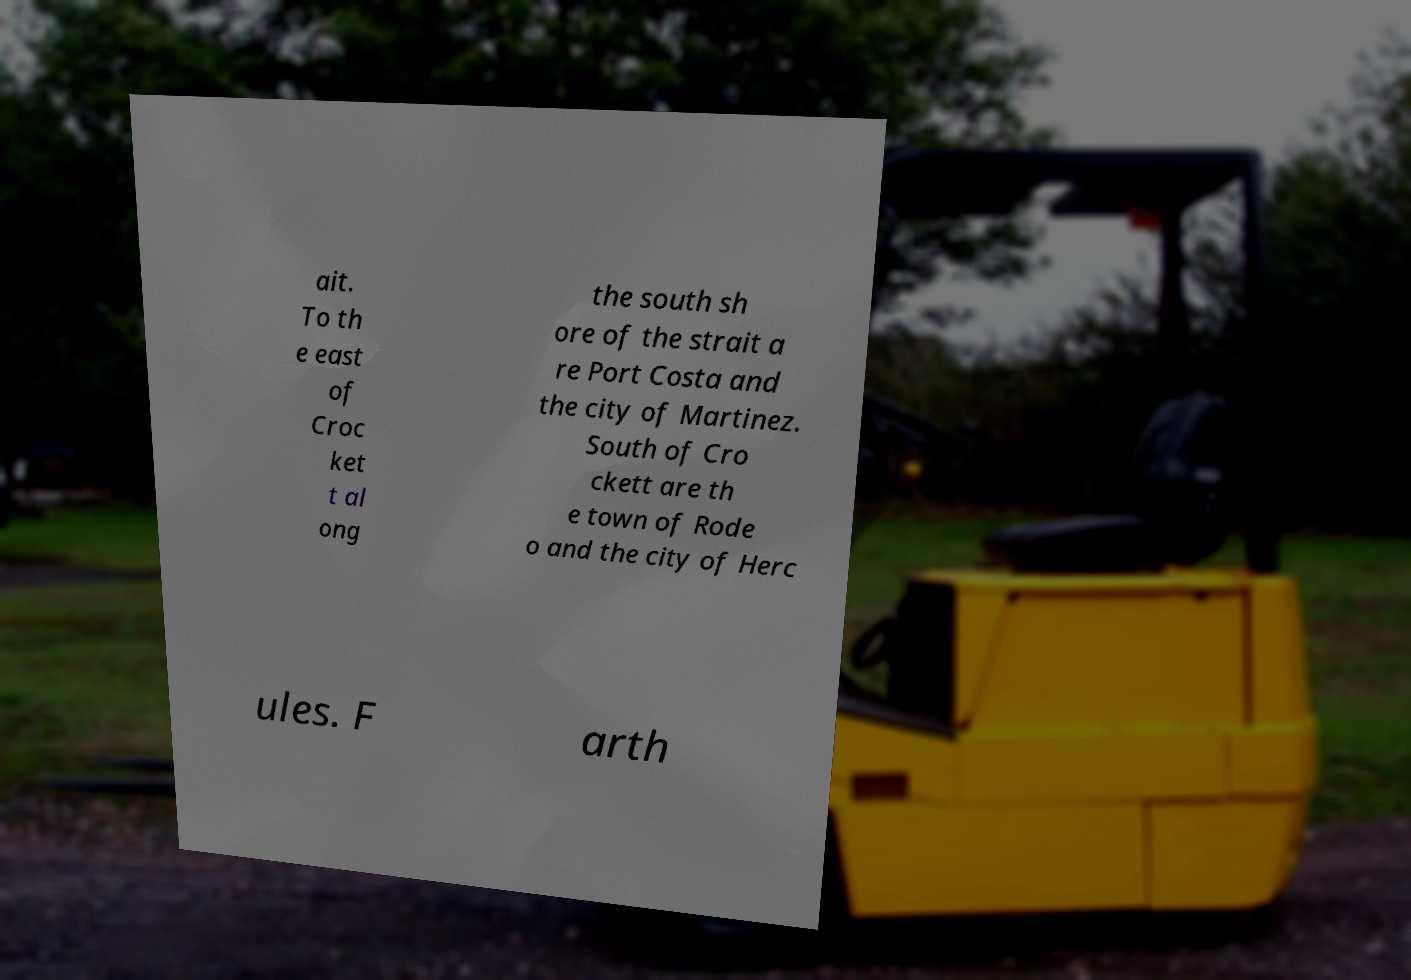Can you read and provide the text displayed in the image?This photo seems to have some interesting text. Can you extract and type it out for me? ait. To th e east of Croc ket t al ong the south sh ore of the strait a re Port Costa and the city of Martinez. South of Cro ckett are th e town of Rode o and the city of Herc ules. F arth 